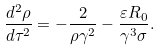<formula> <loc_0><loc_0><loc_500><loc_500>\frac { d ^ { 2 } \rho } { d \tau ^ { 2 } } = - \frac { 2 } { \rho \gamma ^ { 2 } } - \frac { \varepsilon R _ { 0 } } { \gamma ^ { 3 } \sigma } .</formula> 